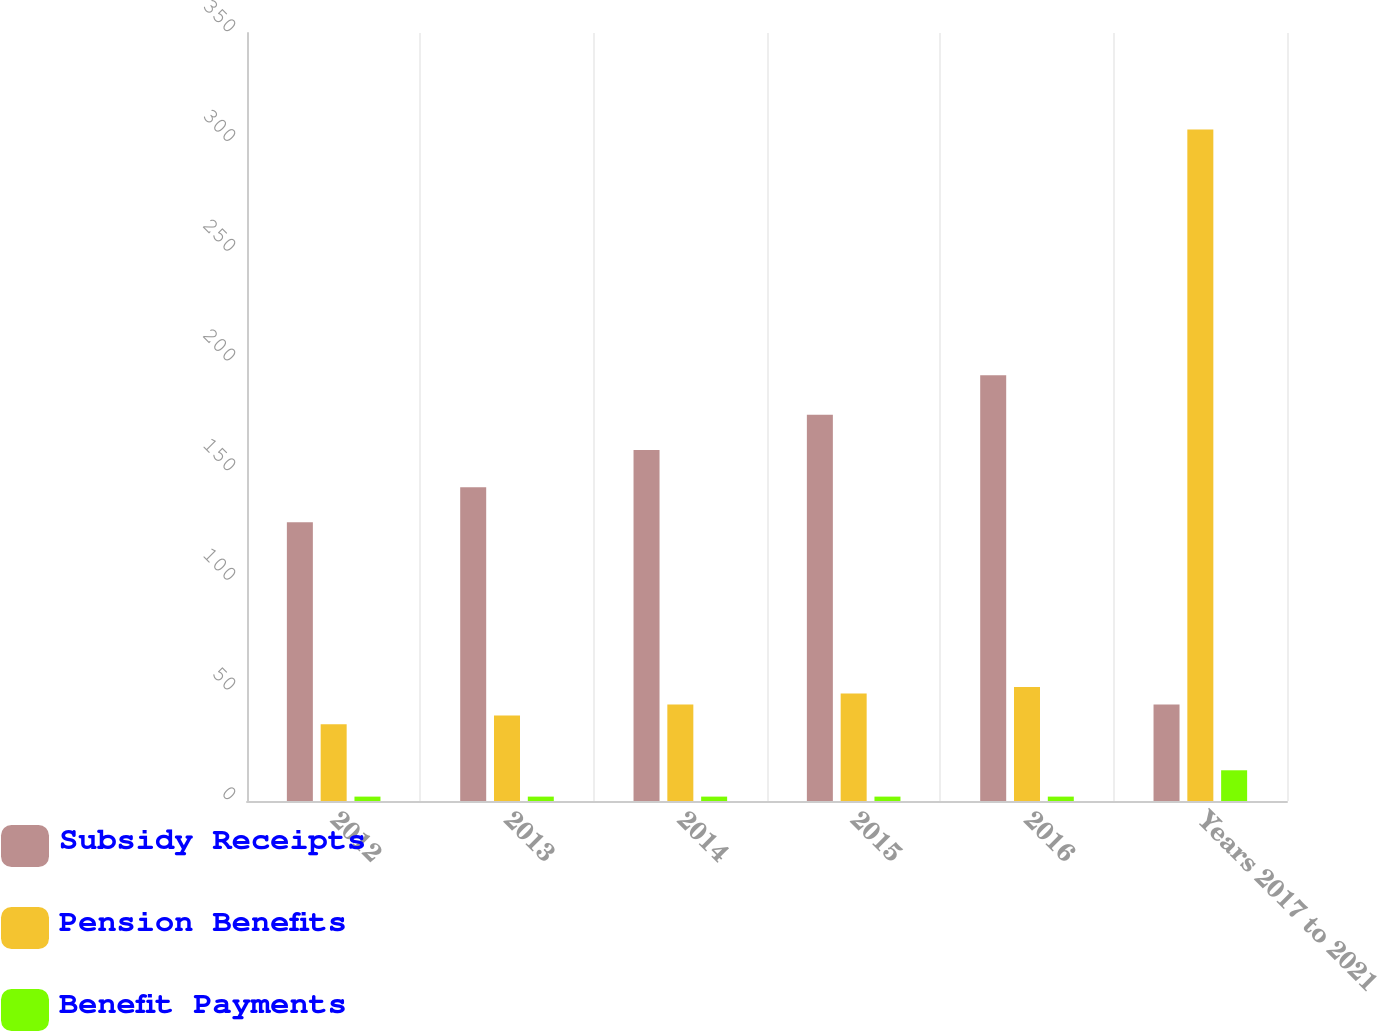Convert chart. <chart><loc_0><loc_0><loc_500><loc_500><stacked_bar_chart><ecel><fcel>2012<fcel>2013<fcel>2014<fcel>2015<fcel>2016<fcel>Years 2017 to 2021<nl><fcel>Subsidy Receipts<fcel>127<fcel>143<fcel>160<fcel>176<fcel>194<fcel>44<nl><fcel>Pension Benefits<fcel>35<fcel>39<fcel>44<fcel>49<fcel>52<fcel>306<nl><fcel>Benefit Payments<fcel>2<fcel>2<fcel>2<fcel>2<fcel>2<fcel>14<nl></chart> 